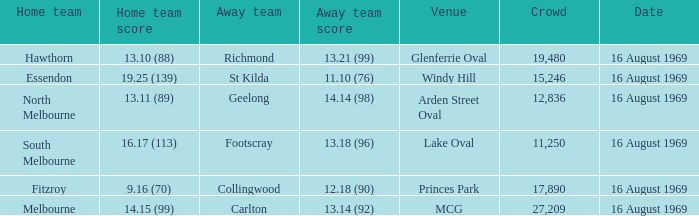Who was home at Princes Park? 9.16 (70). 